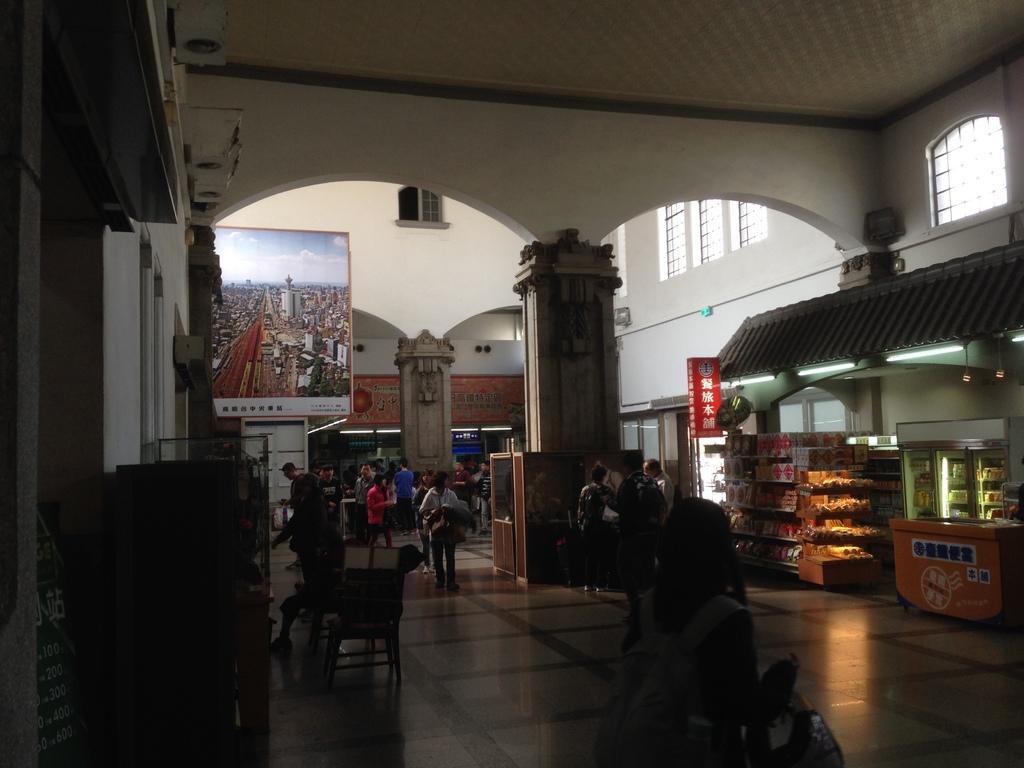Please provide a concise description of this image. This picture shows an inner view of a building and we see few stores and a photo frame to the wall and we see few people standing. 